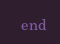Convert code to text. <code><loc_0><loc_0><loc_500><loc_500><_Ruby_>  end</code> 